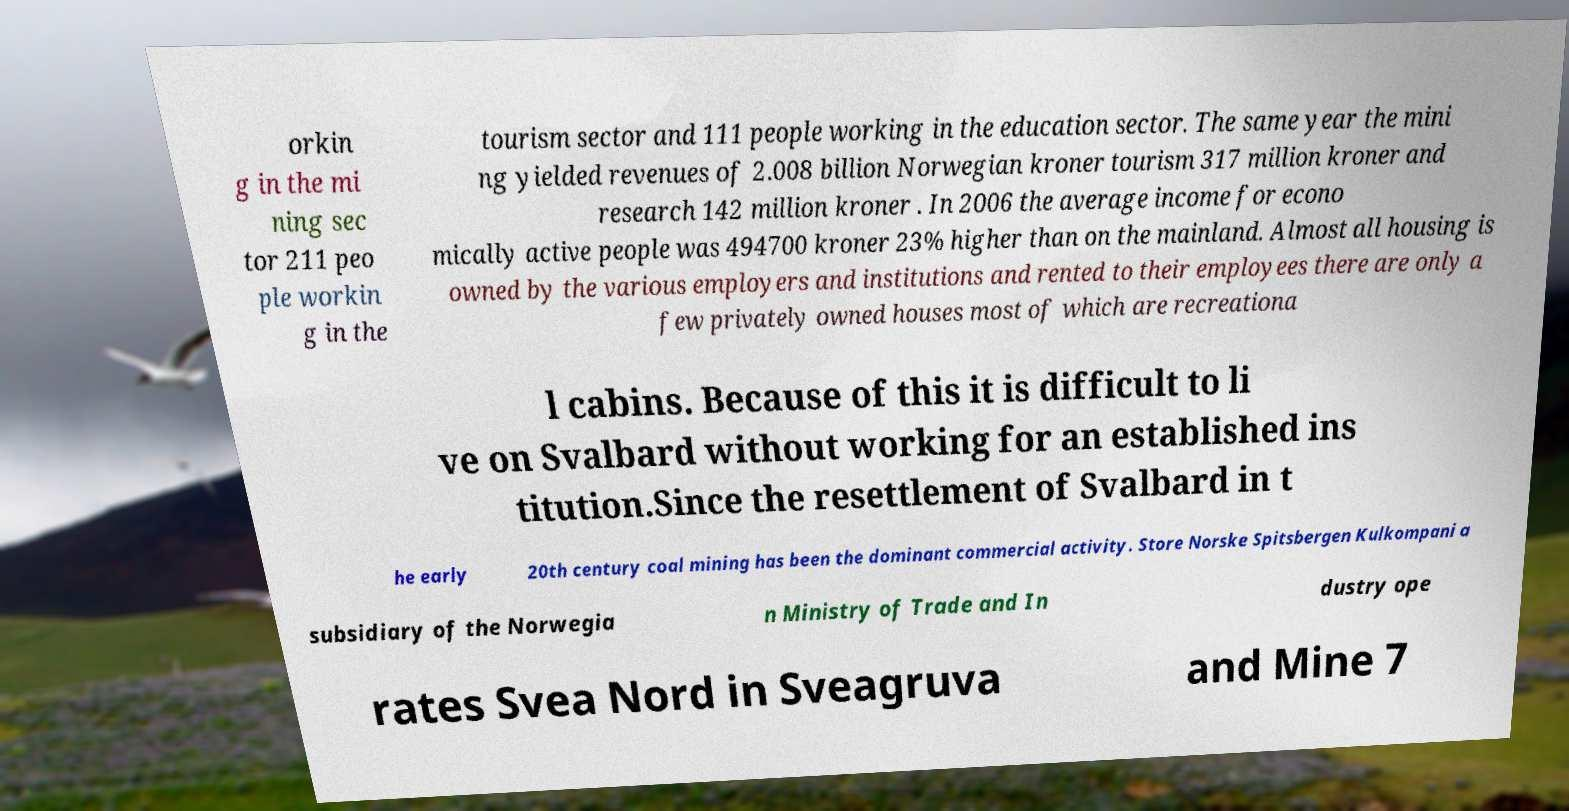I need the written content from this picture converted into text. Can you do that? orkin g in the mi ning sec tor 211 peo ple workin g in the tourism sector and 111 people working in the education sector. The same year the mini ng yielded revenues of 2.008 billion Norwegian kroner tourism 317 million kroner and research 142 million kroner . In 2006 the average income for econo mically active people was 494700 kroner 23% higher than on the mainland. Almost all housing is owned by the various employers and institutions and rented to their employees there are only a few privately owned houses most of which are recreationa l cabins. Because of this it is difficult to li ve on Svalbard without working for an established ins titution.Since the resettlement of Svalbard in t he early 20th century coal mining has been the dominant commercial activity. Store Norske Spitsbergen Kulkompani a subsidiary of the Norwegia n Ministry of Trade and In dustry ope rates Svea Nord in Sveagruva and Mine 7 